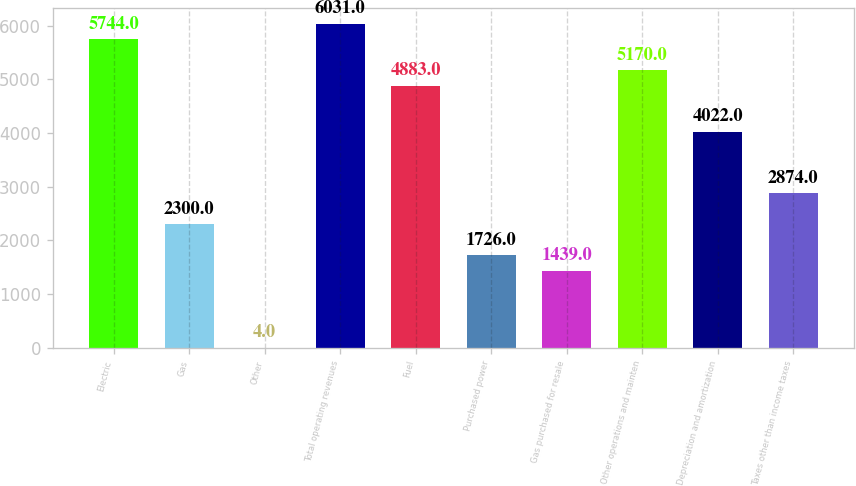Convert chart to OTSL. <chart><loc_0><loc_0><loc_500><loc_500><bar_chart><fcel>Electric<fcel>Gas<fcel>Other<fcel>Total operating revenues<fcel>Fuel<fcel>Purchased power<fcel>Gas purchased for resale<fcel>Other operations and mainten<fcel>Depreciation and amortization<fcel>Taxes other than income taxes<nl><fcel>5744<fcel>2300<fcel>4<fcel>6031<fcel>4883<fcel>1726<fcel>1439<fcel>5170<fcel>4022<fcel>2874<nl></chart> 